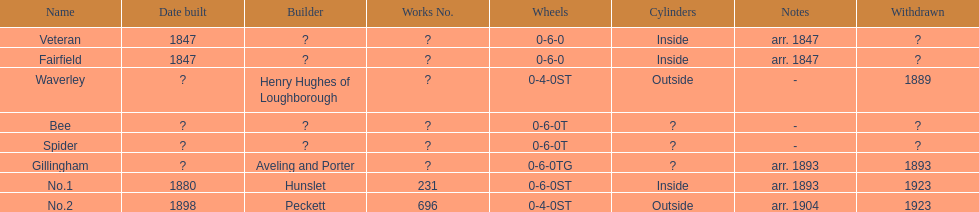Is 1847 the year of construction for no.1 or veteran? Veteran. 